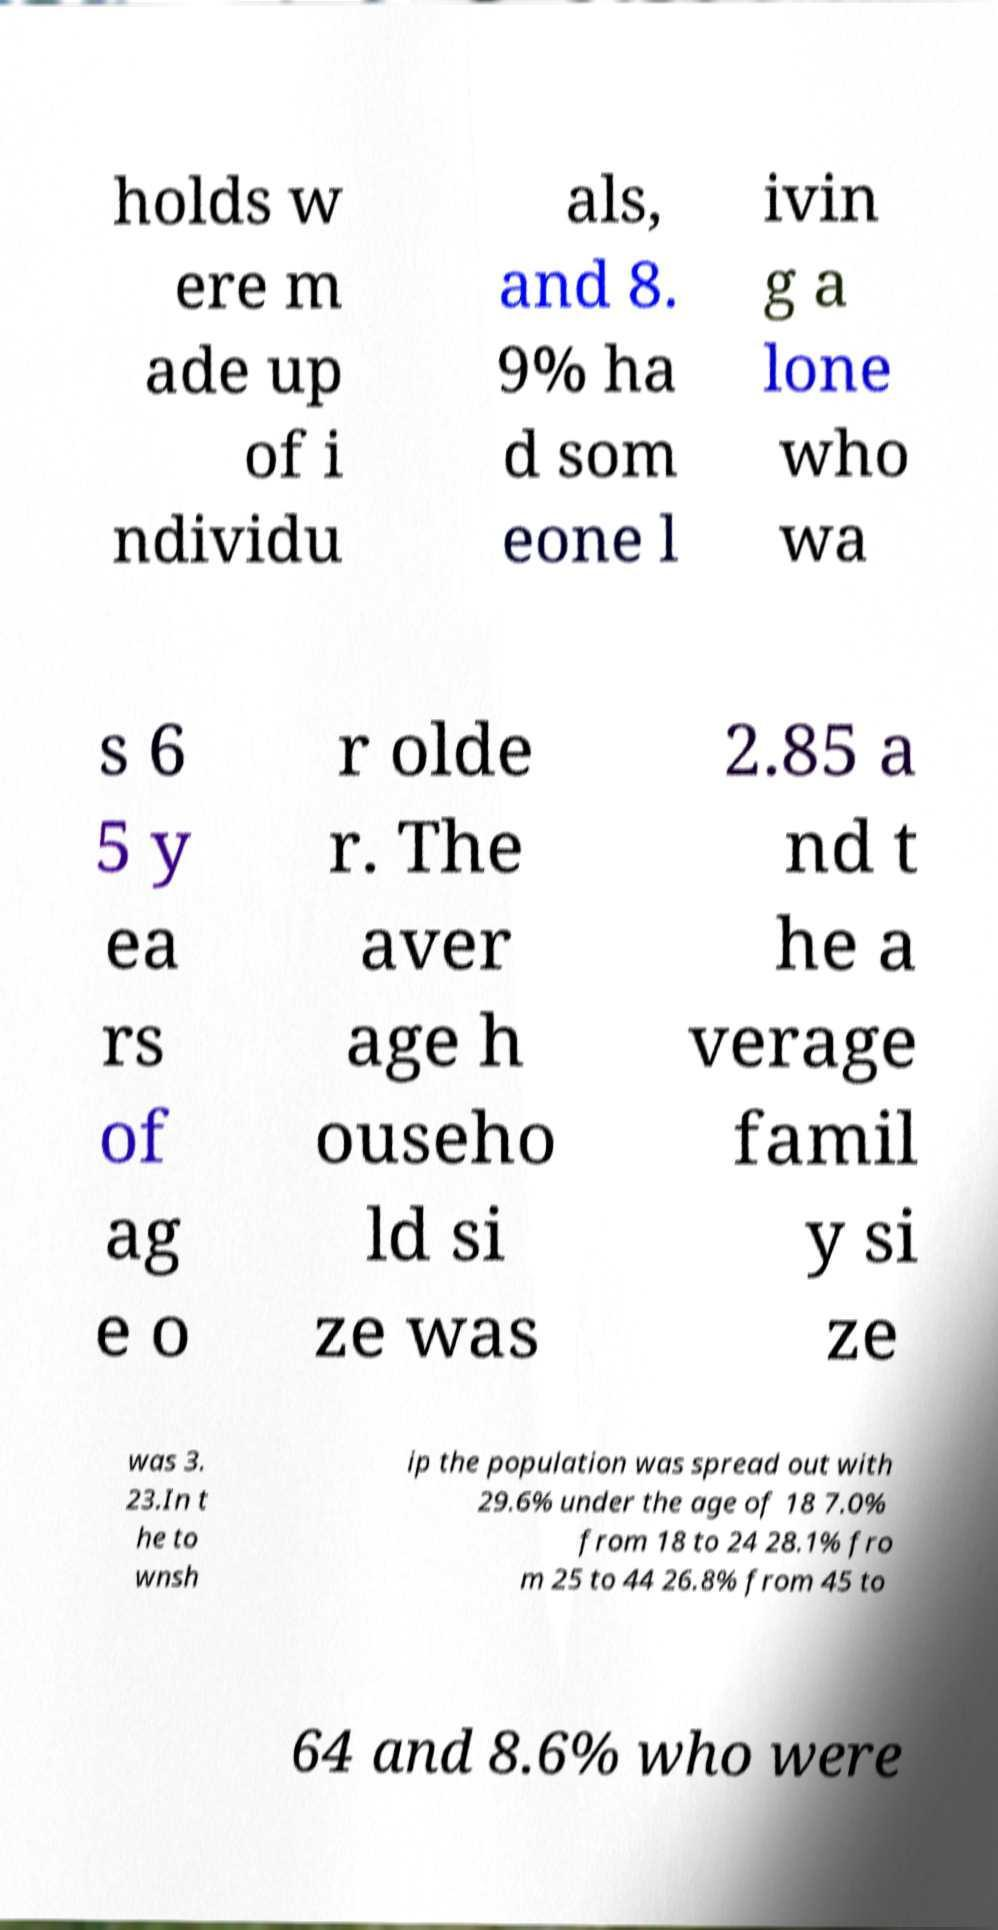Please read and relay the text visible in this image. What does it say? holds w ere m ade up of i ndividu als, and 8. 9% ha d som eone l ivin g a lone who wa s 6 5 y ea rs of ag e o r olde r. The aver age h ouseho ld si ze was 2.85 a nd t he a verage famil y si ze was 3. 23.In t he to wnsh ip the population was spread out with 29.6% under the age of 18 7.0% from 18 to 24 28.1% fro m 25 to 44 26.8% from 45 to 64 and 8.6% who were 